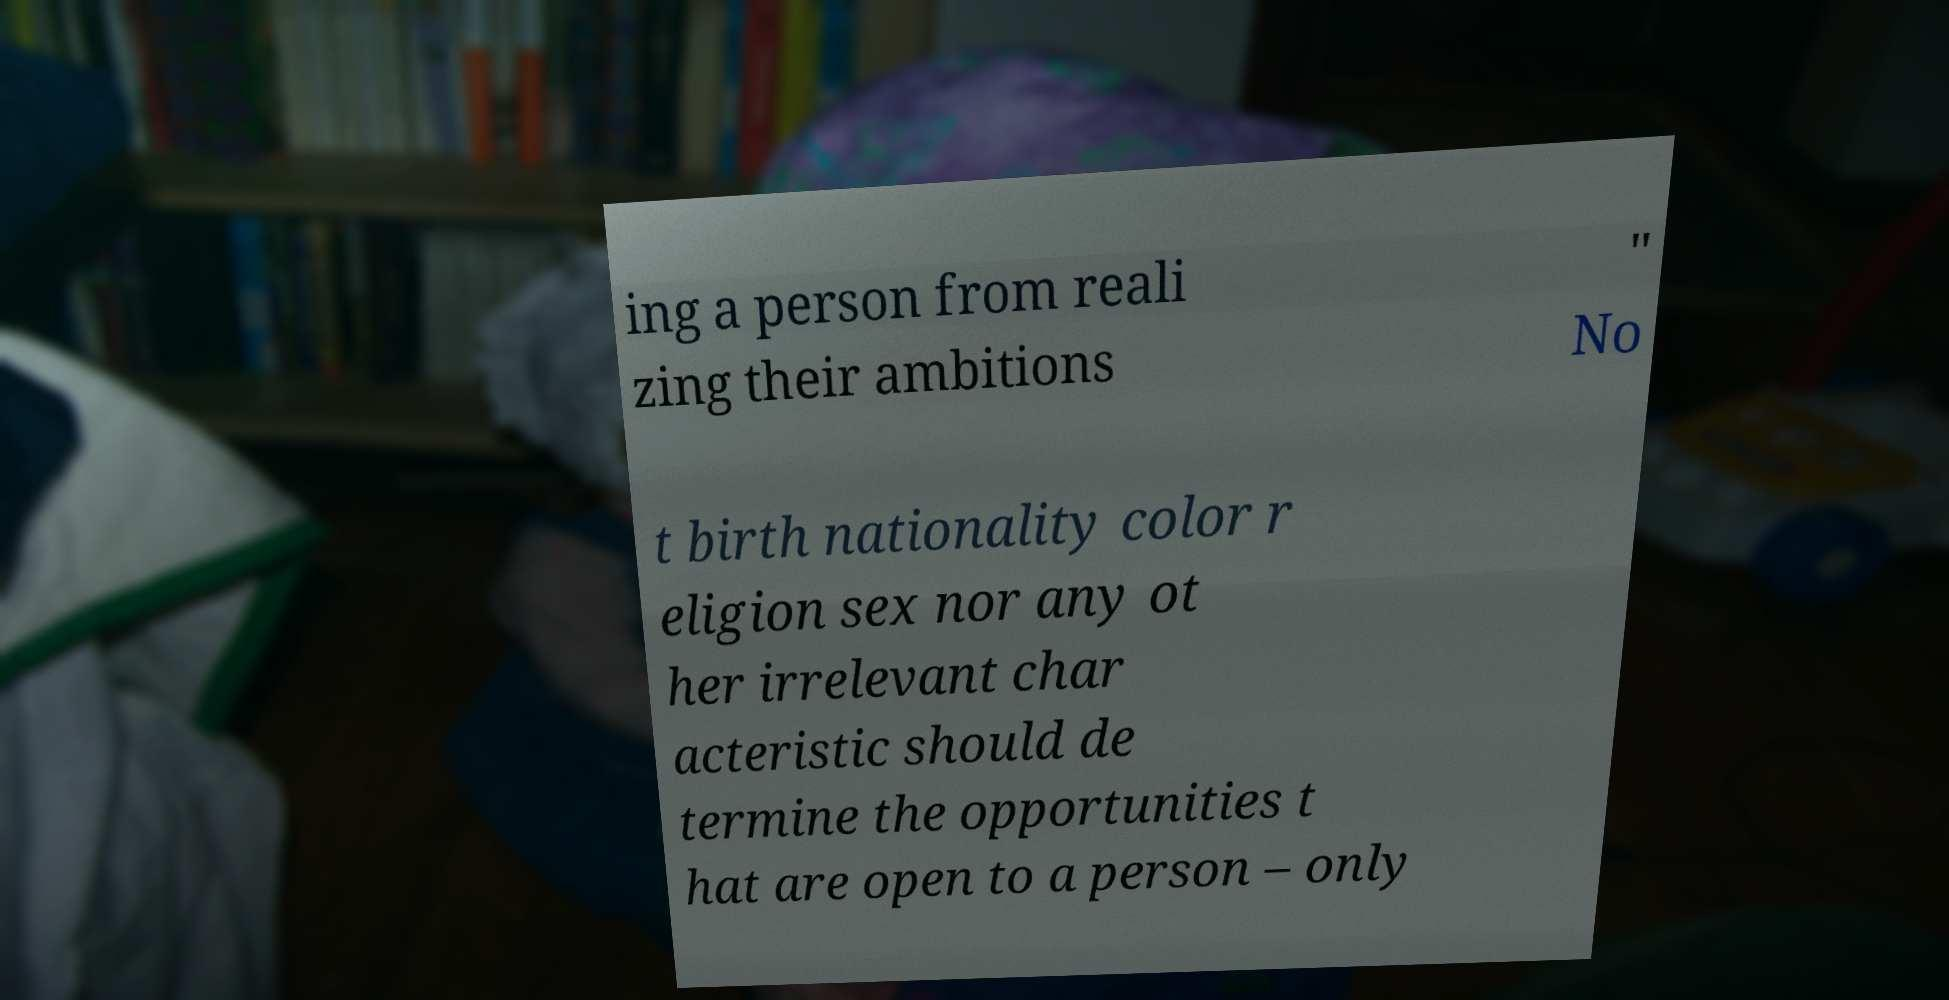Could you extract and type out the text from this image? ing a person from reali zing their ambitions " No t birth nationality color r eligion sex nor any ot her irrelevant char acteristic should de termine the opportunities t hat are open to a person – only 